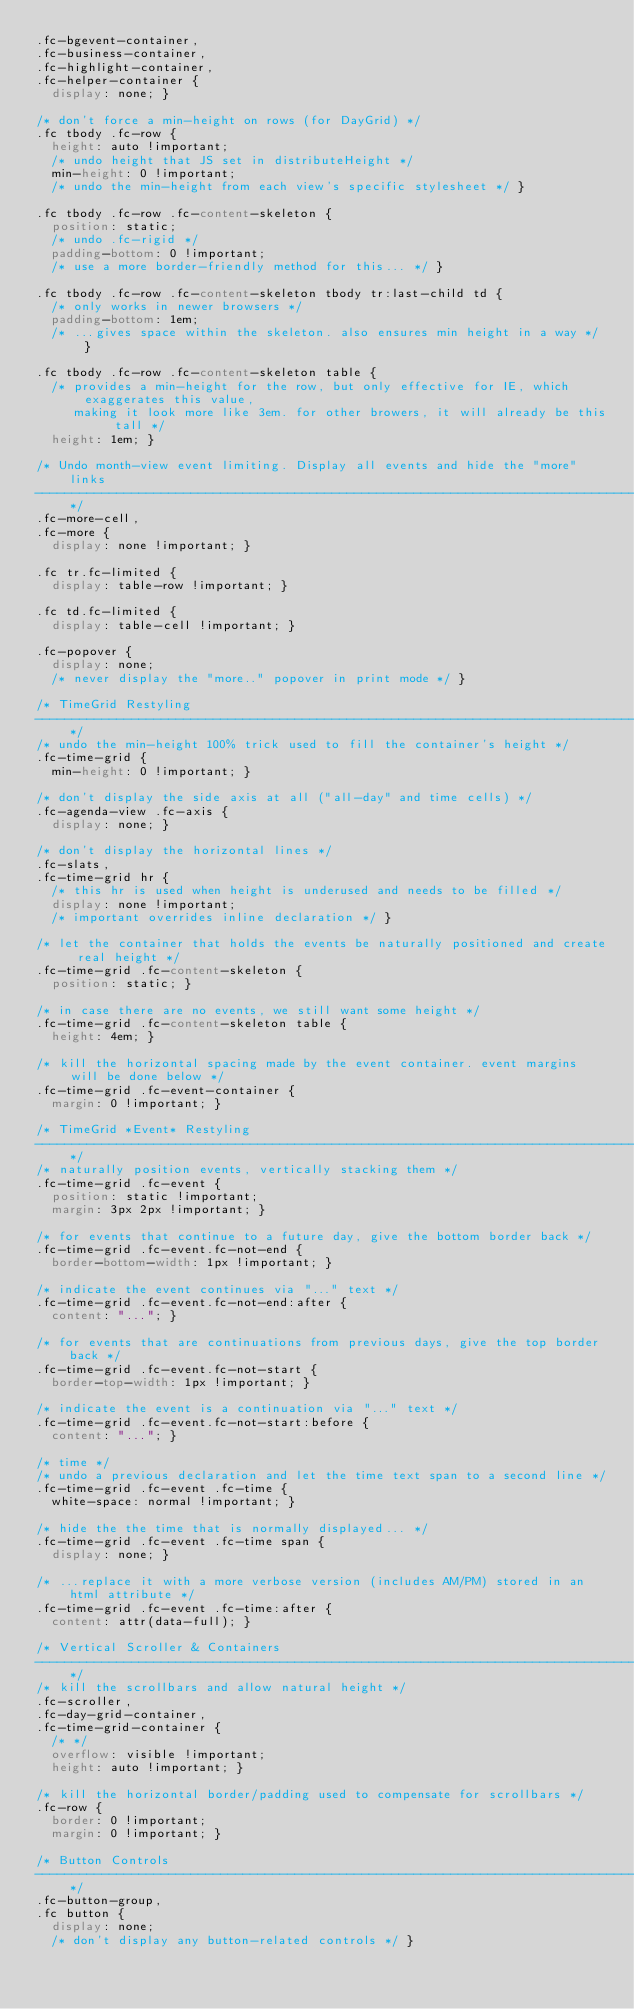Convert code to text. <code><loc_0><loc_0><loc_500><loc_500><_CSS_>.fc-bgevent-container,
.fc-business-container,
.fc-highlight-container,
.fc-helper-container {
  display: none; }

/* don't force a min-height on rows (for DayGrid) */
.fc tbody .fc-row {
  height: auto !important;
  /* undo height that JS set in distributeHeight */
  min-height: 0 !important;
  /* undo the min-height from each view's specific stylesheet */ }

.fc tbody .fc-row .fc-content-skeleton {
  position: static;
  /* undo .fc-rigid */
  padding-bottom: 0 !important;
  /* use a more border-friendly method for this... */ }

.fc tbody .fc-row .fc-content-skeleton tbody tr:last-child td {
  /* only works in newer browsers */
  padding-bottom: 1em;
  /* ...gives space within the skeleton. also ensures min height in a way */ }

.fc tbody .fc-row .fc-content-skeleton table {
  /* provides a min-height for the row, but only effective for IE, which exaggerates this value,
     making it look more like 3em. for other browers, it will already be this tall */
  height: 1em; }

/* Undo month-view event limiting. Display all events and hide the "more" links
--------------------------------------------------------------------------------------------------*/
.fc-more-cell,
.fc-more {
  display: none !important; }

.fc tr.fc-limited {
  display: table-row !important; }

.fc td.fc-limited {
  display: table-cell !important; }

.fc-popover {
  display: none;
  /* never display the "more.." popover in print mode */ }

/* TimeGrid Restyling
--------------------------------------------------------------------------------------------------*/
/* undo the min-height 100% trick used to fill the container's height */
.fc-time-grid {
  min-height: 0 !important; }

/* don't display the side axis at all ("all-day" and time cells) */
.fc-agenda-view .fc-axis {
  display: none; }

/* don't display the horizontal lines */
.fc-slats,
.fc-time-grid hr {
  /* this hr is used when height is underused and needs to be filled */
  display: none !important;
  /* important overrides inline declaration */ }

/* let the container that holds the events be naturally positioned and create real height */
.fc-time-grid .fc-content-skeleton {
  position: static; }

/* in case there are no events, we still want some height */
.fc-time-grid .fc-content-skeleton table {
  height: 4em; }

/* kill the horizontal spacing made by the event container. event margins will be done below */
.fc-time-grid .fc-event-container {
  margin: 0 !important; }

/* TimeGrid *Event* Restyling
--------------------------------------------------------------------------------------------------*/
/* naturally position events, vertically stacking them */
.fc-time-grid .fc-event {
  position: static !important;
  margin: 3px 2px !important; }

/* for events that continue to a future day, give the bottom border back */
.fc-time-grid .fc-event.fc-not-end {
  border-bottom-width: 1px !important; }

/* indicate the event continues via "..." text */
.fc-time-grid .fc-event.fc-not-end:after {
  content: "..."; }

/* for events that are continuations from previous days, give the top border back */
.fc-time-grid .fc-event.fc-not-start {
  border-top-width: 1px !important; }

/* indicate the event is a continuation via "..." text */
.fc-time-grid .fc-event.fc-not-start:before {
  content: "..."; }

/* time */
/* undo a previous declaration and let the time text span to a second line */
.fc-time-grid .fc-event .fc-time {
  white-space: normal !important; }

/* hide the the time that is normally displayed... */
.fc-time-grid .fc-event .fc-time span {
  display: none; }

/* ...replace it with a more verbose version (includes AM/PM) stored in an html attribute */
.fc-time-grid .fc-event .fc-time:after {
  content: attr(data-full); }

/* Vertical Scroller & Containers
--------------------------------------------------------------------------------------------------*/
/* kill the scrollbars and allow natural height */
.fc-scroller,
.fc-day-grid-container,
.fc-time-grid-container {
  /* */
  overflow: visible !important;
  height: auto !important; }

/* kill the horizontal border/padding used to compensate for scrollbars */
.fc-row {
  border: 0 !important;
  margin: 0 !important; }

/* Button Controls
--------------------------------------------------------------------------------------------------*/
.fc-button-group,
.fc button {
  display: none;
  /* don't display any button-related controls */ }</code> 